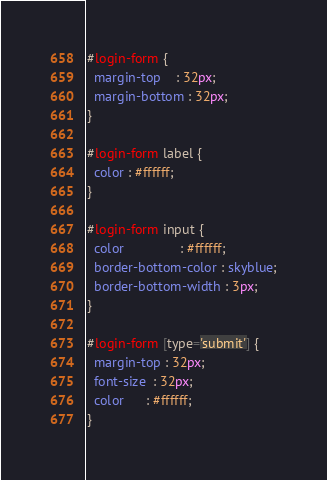<code> <loc_0><loc_0><loc_500><loc_500><_CSS_>#login-form {
  margin-top    : 32px;
  margin-bottom : 32px;
}

#login-form label {
  color : #ffffff;
}

#login-form input {
  color               : #ffffff;
  border-bottom-color : skyblue;
  border-bottom-width : 3px;
}

#login-form [type='submit'] {
  margin-top : 32px;
  font-size  : 32px;
  color      : #ffffff;
}
</code> 